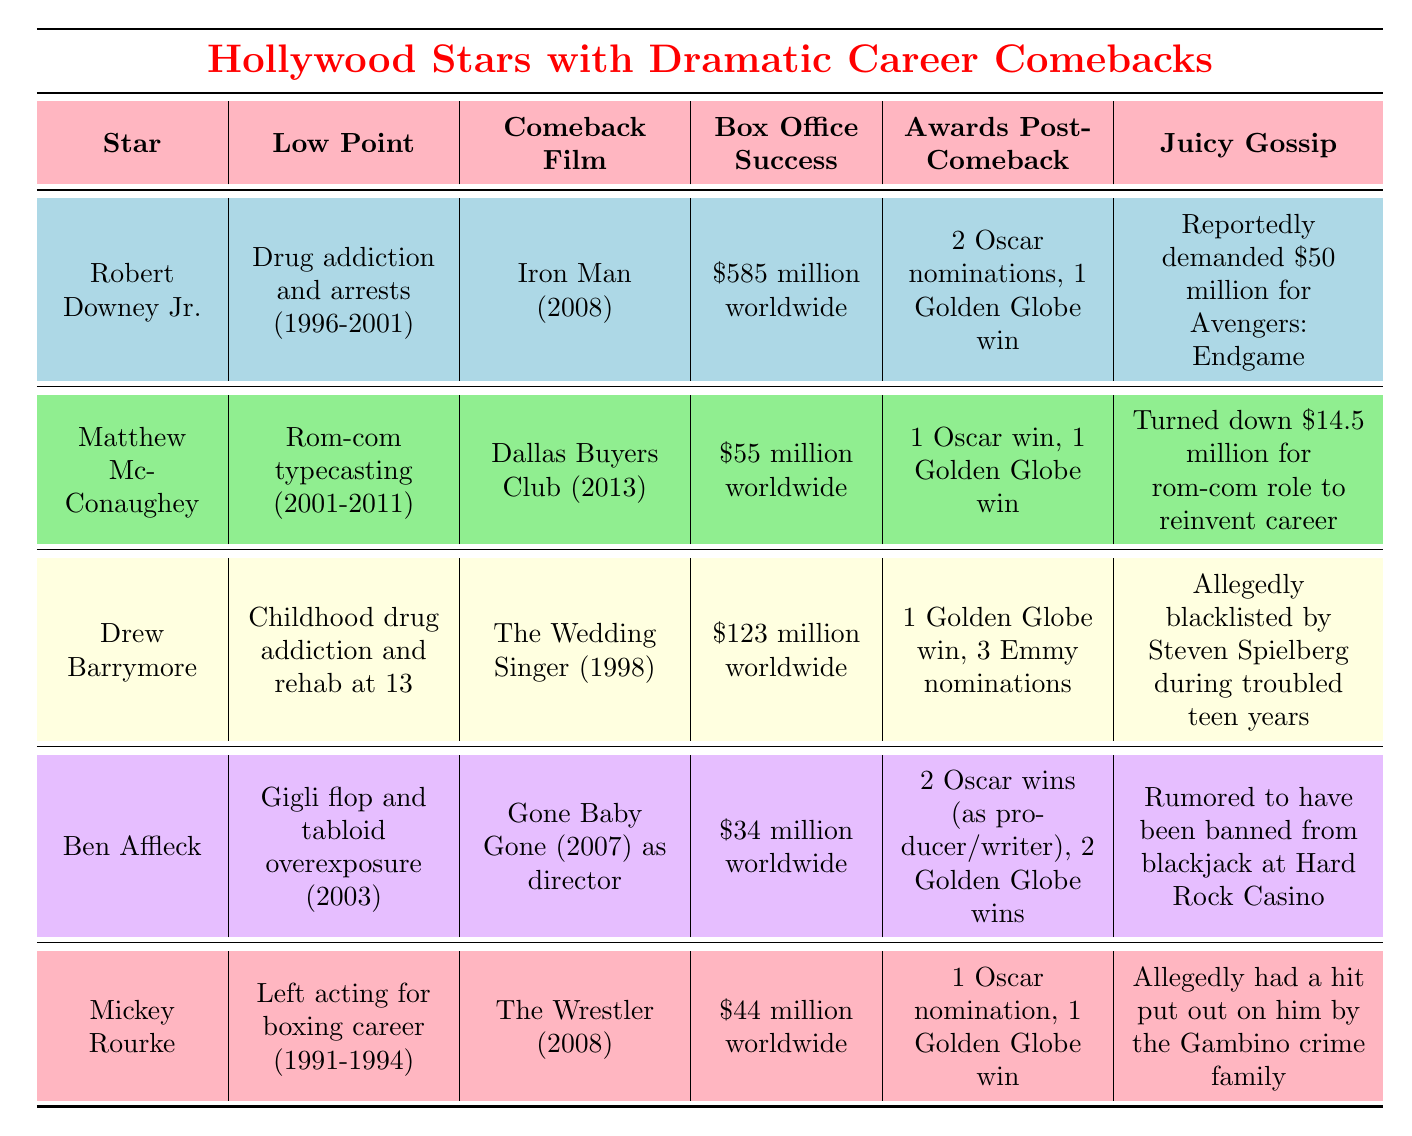What was Robert Downey Jr.'s low point before his comeback? According to the table, Robert Downey Jr.'s low point was drug addiction and arrests, which occurred between 1996 and 2001.
Answer: Drug addiction and arrests (1996-2001) Which star had the highest box office success after their comeback? The table shows that Robert Downey Jr.'s comeback film "Iron Man" had a box office success of $585 million worldwide, which is higher than the others listed.
Answer: $585 million worldwide Did Drew Barrymore receive any awards after her comeback? The table states that after her comeback, Drew Barrymore received 1 Golden Globe win and 3 Emmy nominations, indicating that she did receive awards.
Answer: Yes Which star turned down a significant salary to reinvent their career? According to the table, Matthew McConaughey turned down $14.5 million for a rom-com role to reinvent his career, which directly answers the question.
Answer: Matthew McConaughey What is the collective box office success of Ben Affleck and Mickey Rourke's comeback films? To find their collective box office success, we add Ben Affleck's $34 million from "Gone Baby Gone" and Mickey Rourke's $44 million from "The Wrestler": $34 million + $44 million = $78 million.
Answer: $78 million worldwide 